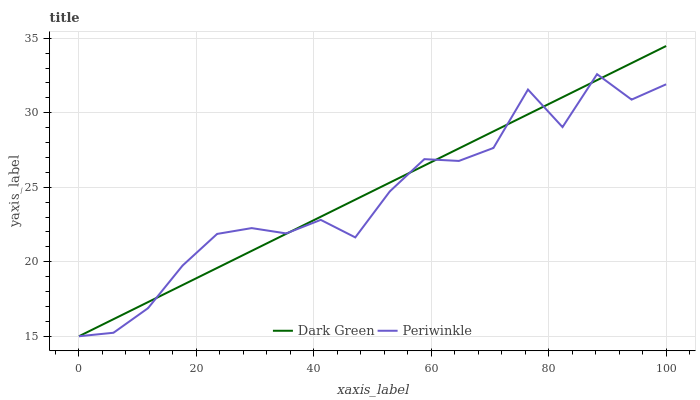Does Periwinkle have the minimum area under the curve?
Answer yes or no. Yes. Does Dark Green have the maximum area under the curve?
Answer yes or no. Yes. Does Dark Green have the minimum area under the curve?
Answer yes or no. No. Is Dark Green the smoothest?
Answer yes or no. Yes. Is Periwinkle the roughest?
Answer yes or no. Yes. Is Dark Green the roughest?
Answer yes or no. No. Does Periwinkle have the lowest value?
Answer yes or no. Yes. Does Dark Green have the highest value?
Answer yes or no. Yes. Does Dark Green intersect Periwinkle?
Answer yes or no. Yes. Is Dark Green less than Periwinkle?
Answer yes or no. No. Is Dark Green greater than Periwinkle?
Answer yes or no. No. 